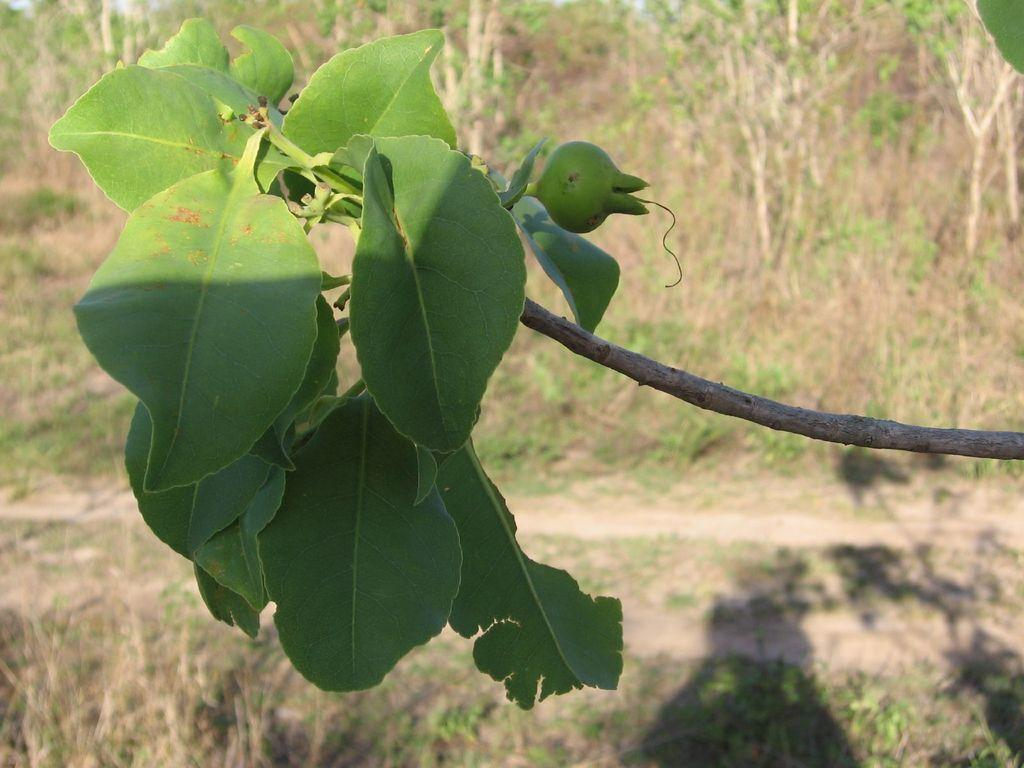What type of plant material is visible in the image? There are leaves in the image. What else can be seen in the image besides leaves? There are fruits and a stem visible in the image. What can be seen in the background of the image? There are trees in the background of the image. How many jellyfish are swimming in the image? There are no jellyfish present in the image; it features plant-related elements such as leaves, fruits, and a stem. 